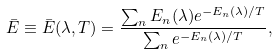<formula> <loc_0><loc_0><loc_500><loc_500>\bar { E } \equiv \bar { E } ( \lambda , T ) = \frac { \sum _ { n } E _ { n } ( \lambda ) e ^ { - E _ { n } ( \lambda ) / T } } { \sum _ { n } e ^ { - E _ { n } ( \lambda ) / T } } ,</formula> 